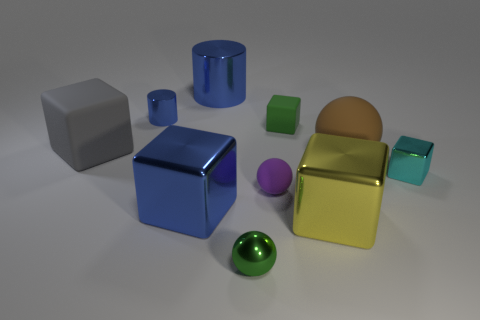Which object in the image seems out of place considering the rest? The green spherical object on the bottom-left stands out due to its shape and color. While most objects exhibit a more angular form as cubes or cuboids, the sphere breaks the pattern and draws attention. 